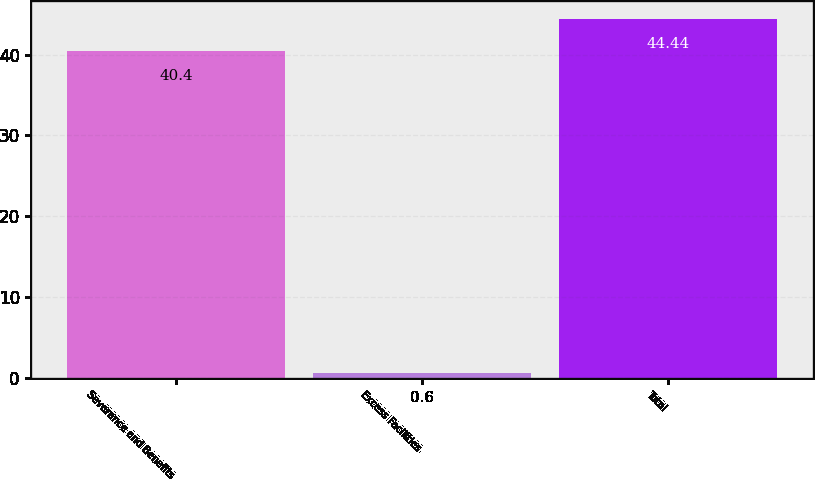<chart> <loc_0><loc_0><loc_500><loc_500><bar_chart><fcel>Severance and Benefits<fcel>Excess Facilities<fcel>Total<nl><fcel>40.4<fcel>0.6<fcel>44.44<nl></chart> 